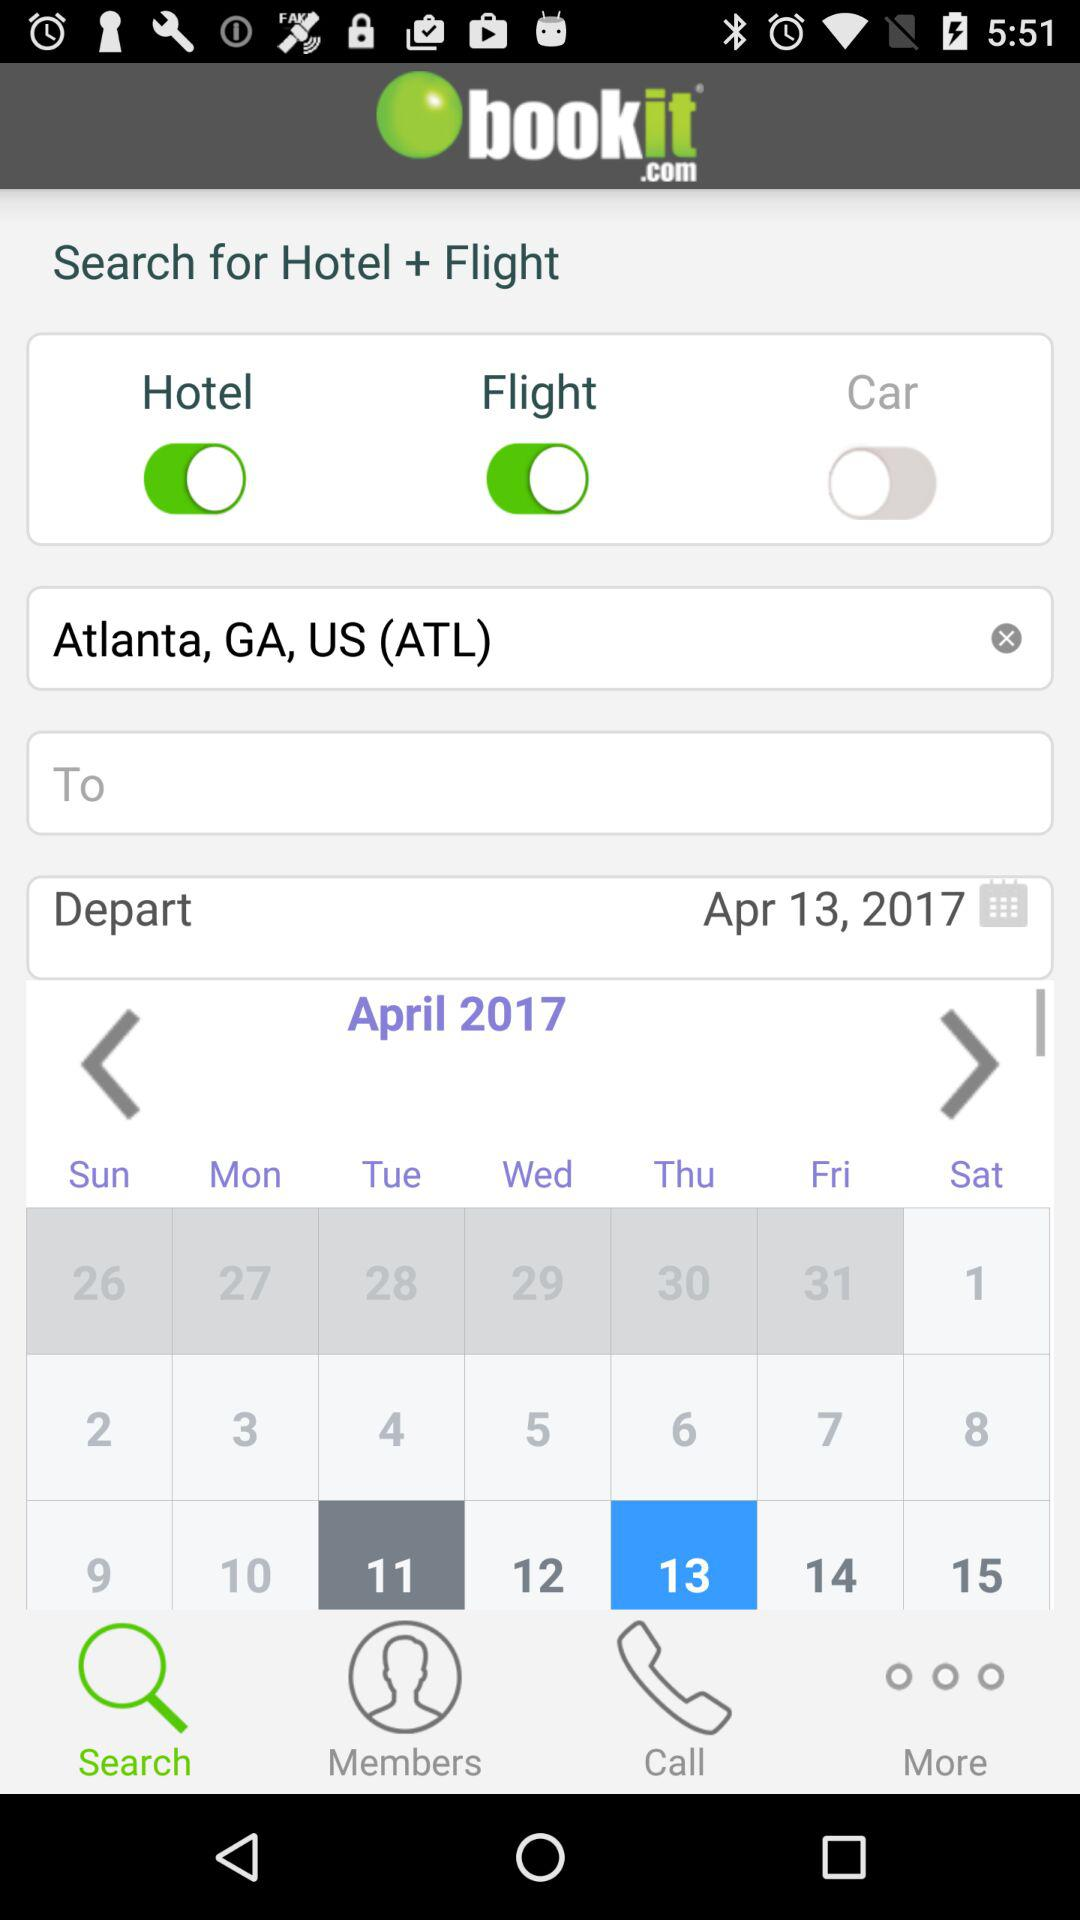What's the scheduled departure date? The scheduled departure date is April 13, 2017. 